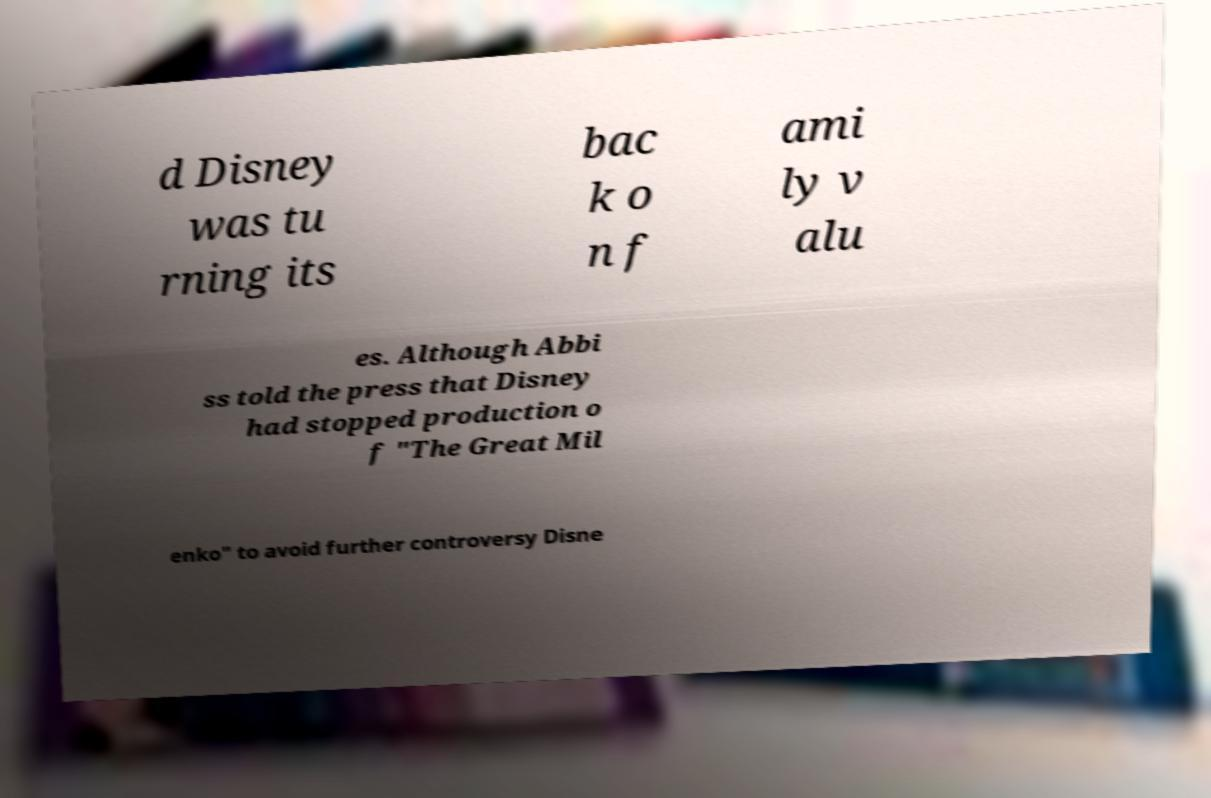Can you accurately transcribe the text from the provided image for me? d Disney was tu rning its bac k o n f ami ly v alu es. Although Abbi ss told the press that Disney had stopped production o f "The Great Mil enko" to avoid further controversy Disne 